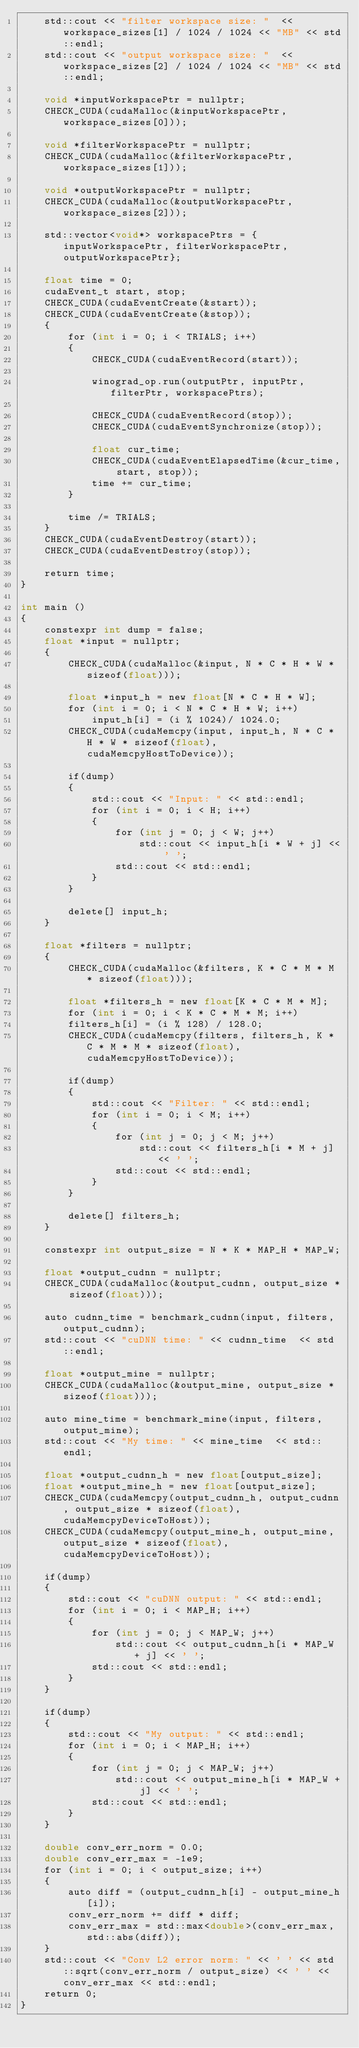Convert code to text. <code><loc_0><loc_0><loc_500><loc_500><_Cuda_>    std::cout << "filter workspace size: "  << workspace_sizes[1] / 1024 / 1024 << "MB" << std::endl;
    std::cout << "output workspace size: "  << workspace_sizes[2] / 1024 / 1024 << "MB" << std::endl;

    void *inputWorkspacePtr = nullptr;
    CHECK_CUDA(cudaMalloc(&inputWorkspacePtr, workspace_sizes[0]));

    void *filterWorkspacePtr = nullptr;
    CHECK_CUDA(cudaMalloc(&filterWorkspacePtr, workspace_sizes[1]));

    void *outputWorkspacePtr = nullptr;
    CHECK_CUDA(cudaMalloc(&outputWorkspacePtr, workspace_sizes[2]));

    std::vector<void*> workspacePtrs = {inputWorkspacePtr, filterWorkspacePtr, outputWorkspacePtr};

    float time = 0;
    cudaEvent_t start, stop;
    CHECK_CUDA(cudaEventCreate(&start));
    CHECK_CUDA(cudaEventCreate(&stop));
    {
        for (int i = 0; i < TRIALS; i++)
        {
            CHECK_CUDA(cudaEventRecord(start));
        
            winograd_op.run(outputPtr, inputPtr, filterPtr, workspacePtrs);

            CHECK_CUDA(cudaEventRecord(stop));
            CHECK_CUDA(cudaEventSynchronize(stop));

            float cur_time;
            CHECK_CUDA(cudaEventElapsedTime(&cur_time, start, stop));
            time += cur_time;
        }

        time /= TRIALS;
    }
    CHECK_CUDA(cudaEventDestroy(start));
    CHECK_CUDA(cudaEventDestroy(stop));

    return time;
}

int main ()
{
    constexpr int dump = false;
    float *input = nullptr;
    {
        CHECK_CUDA(cudaMalloc(&input, N * C * H * W * sizeof(float)));

        float *input_h = new float[N * C * H * W];
        for (int i = 0; i < N * C * H * W; i++)
            input_h[i] = (i % 1024)/ 1024.0;
        CHECK_CUDA(cudaMemcpy(input, input_h, N * C * H * W * sizeof(float), cudaMemcpyHostToDevice));

        if(dump)
        {
            std::cout << "Input: " << std::endl;
            for (int i = 0; i < H; i++)
            {
                for (int j = 0; j < W; j++)
                    std::cout << input_h[i * W + j] << ' ';
                std::cout << std::endl;
            }
        }

        delete[] input_h;
    }

    float *filters = nullptr;
    {
        CHECK_CUDA(cudaMalloc(&filters, K * C * M * M * sizeof(float)));

        float *filters_h = new float[K * C * M * M];
        for (int i = 0; i < K * C * M * M; i++)
        filters_h[i] = (i % 128) / 128.0;
        CHECK_CUDA(cudaMemcpy(filters, filters_h, K * C * M * M * sizeof(float), cudaMemcpyHostToDevice));

        if(dump)
        {
            std::cout << "Filter: " << std::endl;
            for (int i = 0; i < M; i++)
            {
                for (int j = 0; j < M; j++)
                    std::cout << filters_h[i * M + j] << ' ';
                std::cout << std::endl;
            }
        }

        delete[] filters_h;
    }

    constexpr int output_size = N * K * MAP_H * MAP_W;

    float *output_cudnn = nullptr;
    CHECK_CUDA(cudaMalloc(&output_cudnn, output_size * sizeof(float)));

    auto cudnn_time = benchmark_cudnn(input, filters, output_cudnn);
    std::cout << "cuDNN time: " << cudnn_time  << std::endl;

    float *output_mine = nullptr;
    CHECK_CUDA(cudaMalloc(&output_mine, output_size * sizeof(float)));

    auto mine_time = benchmark_mine(input, filters, output_mine);
    std::cout << "My time: " << mine_time  << std::endl;

    float *output_cudnn_h = new float[output_size];
    float *output_mine_h = new float[output_size];
    CHECK_CUDA(cudaMemcpy(output_cudnn_h, output_cudnn, output_size * sizeof(float), cudaMemcpyDeviceToHost));
    CHECK_CUDA(cudaMemcpy(output_mine_h, output_mine, output_size * sizeof(float), cudaMemcpyDeviceToHost));

    if(dump)
    {
        std::cout << "cuDNN output: " << std::endl;
        for (int i = 0; i < MAP_H; i++)
        {
            for (int j = 0; j < MAP_W; j++)
                std::cout << output_cudnn_h[i * MAP_W + j] << ' ';
            std::cout << std::endl;
        }
    }

    if(dump)
    {
        std::cout << "My output: " << std::endl;
        for (int i = 0; i < MAP_H; i++)
        {
            for (int j = 0; j < MAP_W; j++)
                std::cout << output_mine_h[i * MAP_W + j] << ' ';
            std::cout << std::endl;
        }
    }

    double conv_err_norm = 0.0;
    double conv_err_max = -1e9;
    for (int i = 0; i < output_size; i++)
    {
        auto diff = (output_cudnn_h[i] - output_mine_h[i]);
        conv_err_norm += diff * diff;
        conv_err_max = std::max<double>(conv_err_max, std::abs(diff));
    }
    std::cout << "Conv L2 error norm: " << ' ' << std::sqrt(conv_err_norm / output_size) << ' ' << conv_err_max << std::endl;
    return 0;
}</code> 